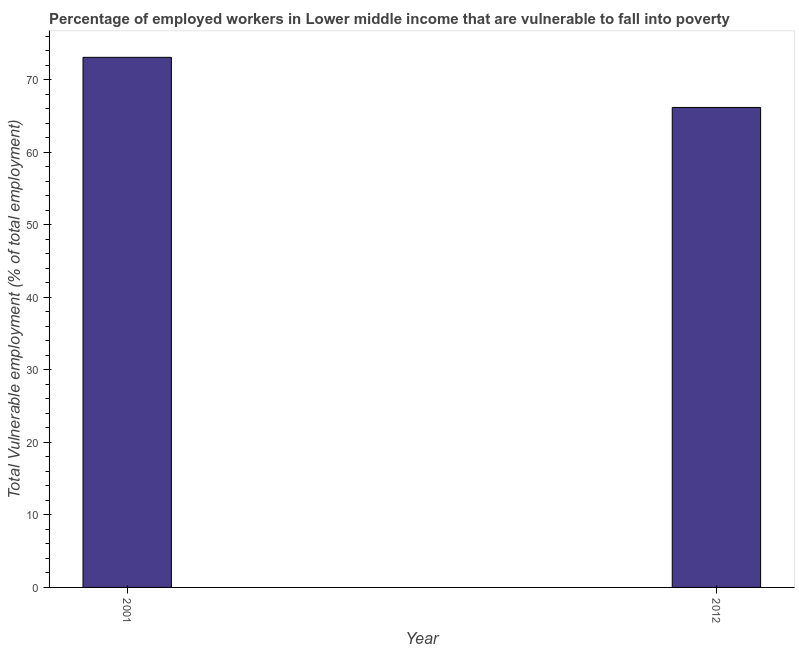Does the graph contain grids?
Make the answer very short. No. What is the title of the graph?
Offer a terse response. Percentage of employed workers in Lower middle income that are vulnerable to fall into poverty. What is the label or title of the Y-axis?
Ensure brevity in your answer.  Total Vulnerable employment (% of total employment). What is the total vulnerable employment in 2001?
Offer a terse response. 73.09. Across all years, what is the maximum total vulnerable employment?
Provide a succinct answer. 73.09. Across all years, what is the minimum total vulnerable employment?
Provide a succinct answer. 66.18. In which year was the total vulnerable employment minimum?
Keep it short and to the point. 2012. What is the sum of the total vulnerable employment?
Provide a short and direct response. 139.26. What is the difference between the total vulnerable employment in 2001 and 2012?
Your response must be concise. 6.91. What is the average total vulnerable employment per year?
Make the answer very short. 69.63. What is the median total vulnerable employment?
Provide a succinct answer. 69.63. In how many years, is the total vulnerable employment greater than 52 %?
Give a very brief answer. 2. What is the ratio of the total vulnerable employment in 2001 to that in 2012?
Offer a terse response. 1.1. Is the total vulnerable employment in 2001 less than that in 2012?
Your answer should be very brief. No. Are the values on the major ticks of Y-axis written in scientific E-notation?
Provide a succinct answer. No. What is the Total Vulnerable employment (% of total employment) in 2001?
Your response must be concise. 73.09. What is the Total Vulnerable employment (% of total employment) in 2012?
Offer a very short reply. 66.18. What is the difference between the Total Vulnerable employment (% of total employment) in 2001 and 2012?
Your answer should be compact. 6.91. What is the ratio of the Total Vulnerable employment (% of total employment) in 2001 to that in 2012?
Offer a terse response. 1.1. 